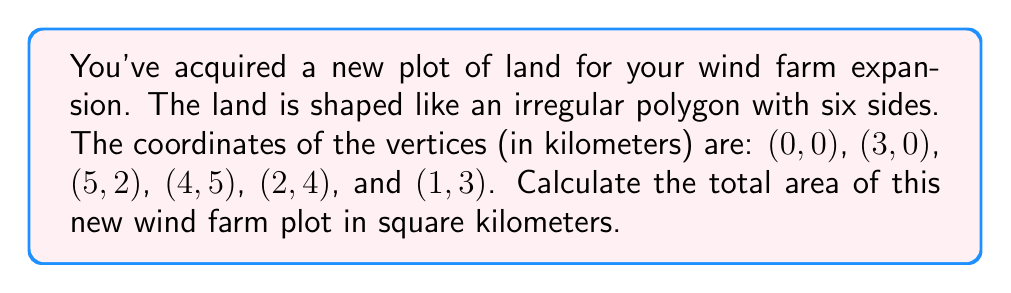Can you solve this math problem? To calculate the area of an irregular polygon given its vertices, we can use the Shoelace formula (also known as the surveyor's formula). The steps are as follows:

1) First, let's list our vertices in order:
   $(x_1,y_1) = (0,0)$
   $(x_2,y_2) = (3,0)$
   $(x_3,y_3) = (5,2)$
   $(x_4,y_4) = (4,5)$
   $(x_5,y_5) = (2,4)$
   $(x_6,y_6) = (1,3)$

2) The Shoelace formula for the area is:

   $$A = \frac{1}{2}|(x_1y_2 + x_2y_3 + x_3y_4 + x_4y_5 + x_5y_6 + x_6y_1) - (y_1x_2 + y_2x_3 + y_3x_4 + y_4x_5 + y_5x_6 + y_6x_1)|$$

3) Let's calculate each term:
   $x_1y_2 = 0 \cdot 0 = 0$
   $x_2y_3 = 3 \cdot 2 = 6$
   $x_3y_4 = 5 \cdot 5 = 25$
   $x_4y_5 = 4 \cdot 4 = 16$
   $x_5y_6 = 2 \cdot 3 = 6$
   $x_6y_1 = 1 \cdot 0 = 0$

   $y_1x_2 = 0 \cdot 3 = 0$
   $y_2x_3 = 0 \cdot 5 = 0$
   $y_3x_4 = 2 \cdot 4 = 8$
   $y_4x_5 = 5 \cdot 2 = 10$
   $y_5x_6 = 4 \cdot 1 = 4$
   $y_6x_1 = 3 \cdot 0 = 0$

4) Sum up the terms:
   $(0 + 6 + 25 + 16 + 6 + 0) - (0 + 0 + 8 + 10 + 4 + 0) = 53 - 22 = 31$

5) Multiply by $\frac{1}{2}$:
   $$A = \frac{1}{2} \cdot 31 = 15.5$$

Therefore, the area of the wind farm is 15.5 square kilometers.
Answer: 15.5 km² 